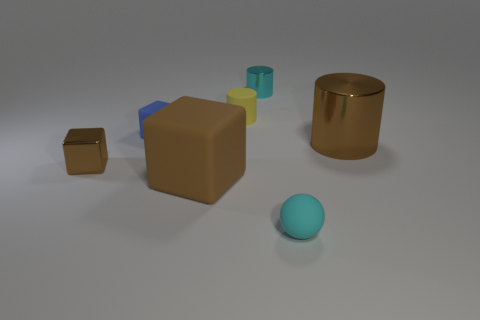What material is the tiny object that is the same color as the small sphere?
Make the answer very short. Metal. What shape is the small thing that is the same color as the large shiny object?
Provide a short and direct response. Cube. What number of cyan things have the same material as the tiny cyan cylinder?
Ensure brevity in your answer.  0. What is the material of the object that is on the right side of the tiny thing that is in front of the tiny metallic thing that is in front of the brown shiny cylinder?
Your response must be concise. Metal. There is a small matte thing that is in front of the metallic object in front of the brown cylinder; what color is it?
Your answer should be compact. Cyan. What is the color of the rubber cylinder that is the same size as the cyan metal cylinder?
Your answer should be very brief. Yellow. How many tiny objects are either cylinders or blue matte blocks?
Provide a short and direct response. 3. Are there more small brown cubes that are behind the large metallic thing than big brown rubber blocks on the right side of the tiny yellow rubber cylinder?
Your answer should be compact. No. There is a cylinder that is the same color as the big matte block; what size is it?
Your response must be concise. Large. How many other objects are the same size as the yellow matte cylinder?
Keep it short and to the point. 4. 